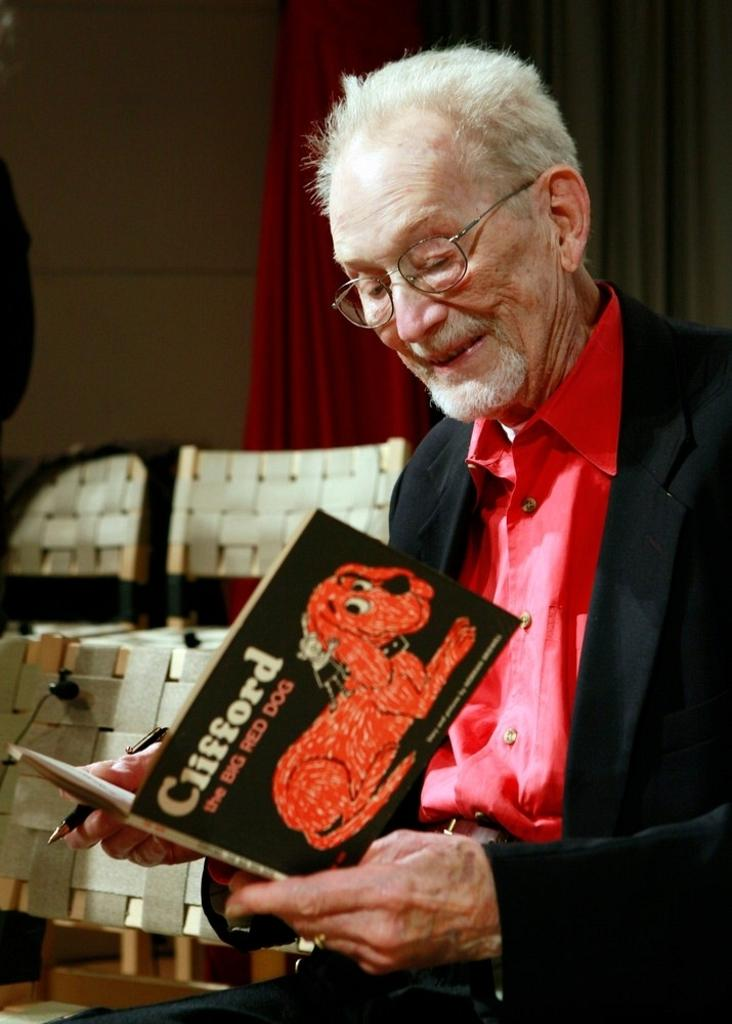What is the person on the right side of the image doing? The person is sitting on a chair and holding a pen. What object does the person have in their possession? The person has a book. What can be seen in the background of the image? There are chairs, a curtain, and a wall in the background of the image. How does the crowd react to the surprise in the image? There is no crowd or surprise present in the image. What type of glove is the person wearing in the image? The person is not wearing a glove in the image. 